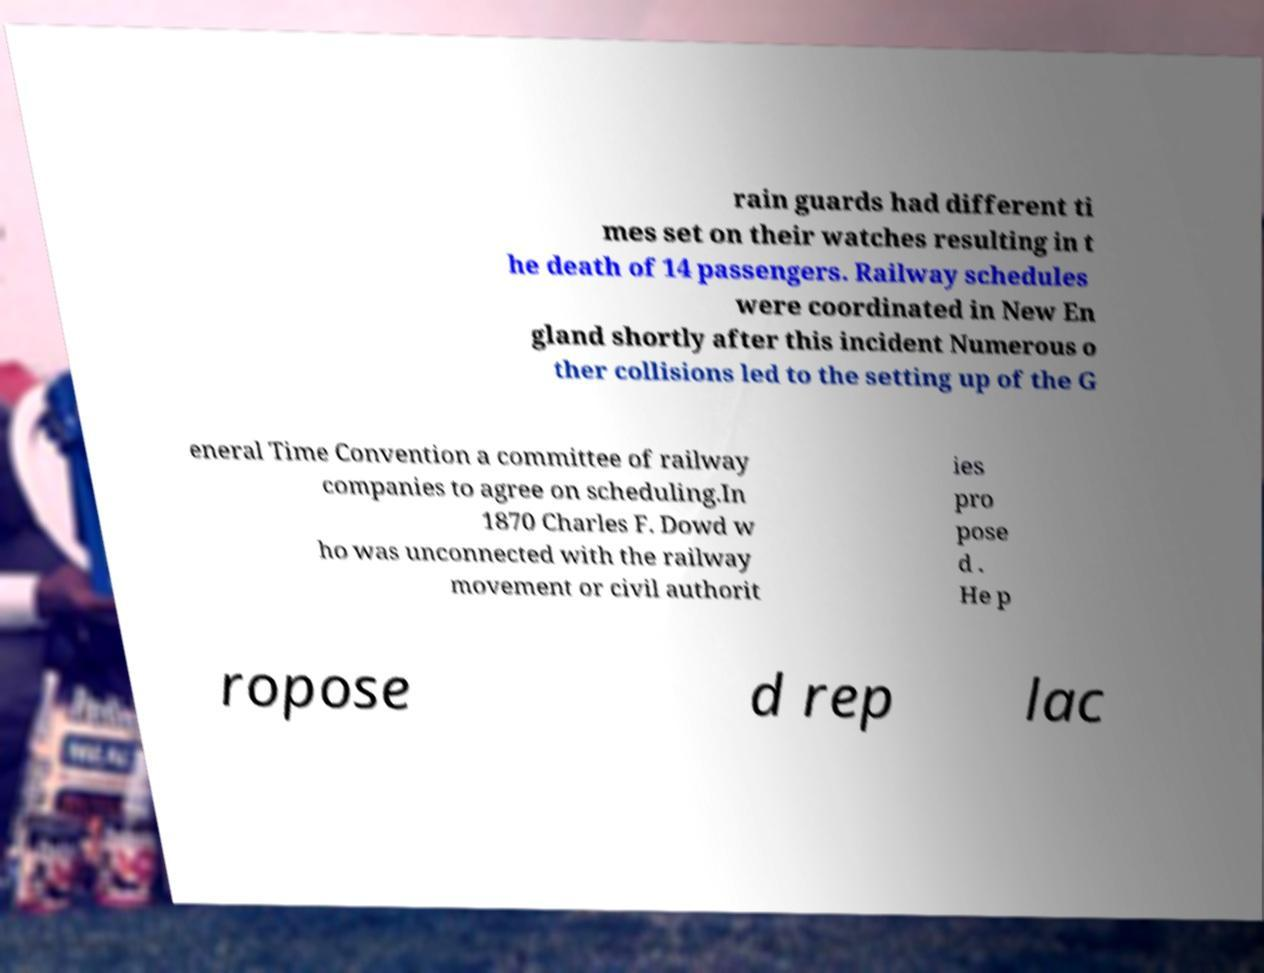I need the written content from this picture converted into text. Can you do that? rain guards had different ti mes set on their watches resulting in t he death of 14 passengers. Railway schedules were coordinated in New En gland shortly after this incident Numerous o ther collisions led to the setting up of the G eneral Time Convention a committee of railway companies to agree on scheduling.In 1870 Charles F. Dowd w ho was unconnected with the railway movement or civil authorit ies pro pose d . He p ropose d rep lac 